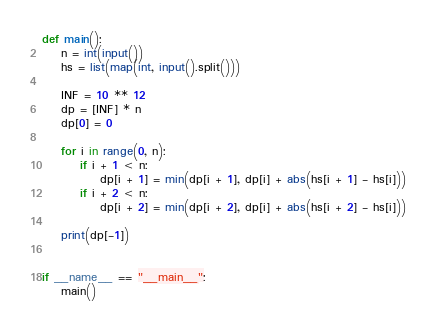Convert code to text. <code><loc_0><loc_0><loc_500><loc_500><_Python_>def main():
    n = int(input())
    hs = list(map(int, input().split()))

    INF = 10 ** 12
    dp = [INF] * n
    dp[0] = 0

    for i in range(0, n):
        if i + 1 < n:
            dp[i + 1] = min(dp[i + 1], dp[i] + abs(hs[i + 1] - hs[i]))
        if i + 2 < n:
            dp[i + 2] = min(dp[i + 2], dp[i] + abs(hs[i + 2] - hs[i]))

    print(dp[-1])


if __name__ == "__main__":
    main()
</code> 